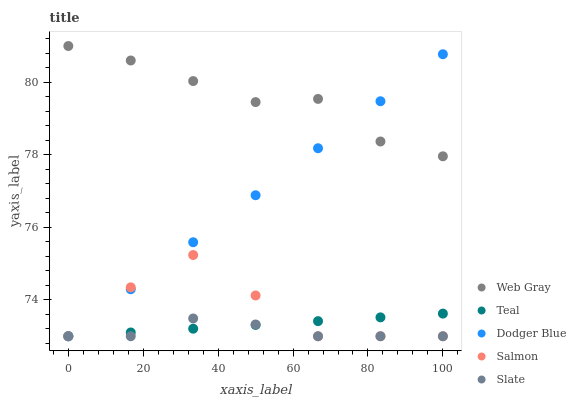Does Slate have the minimum area under the curve?
Answer yes or no. Yes. Does Web Gray have the maximum area under the curve?
Answer yes or no. Yes. Does Web Gray have the minimum area under the curve?
Answer yes or no. No. Does Slate have the maximum area under the curve?
Answer yes or no. No. Is Teal the smoothest?
Answer yes or no. Yes. Is Salmon the roughest?
Answer yes or no. Yes. Is Slate the smoothest?
Answer yes or no. No. Is Slate the roughest?
Answer yes or no. No. Does Salmon have the lowest value?
Answer yes or no. Yes. Does Web Gray have the lowest value?
Answer yes or no. No. Does Web Gray have the highest value?
Answer yes or no. Yes. Does Slate have the highest value?
Answer yes or no. No. Is Teal less than Web Gray?
Answer yes or no. Yes. Is Web Gray greater than Slate?
Answer yes or no. Yes. Does Salmon intersect Slate?
Answer yes or no. Yes. Is Salmon less than Slate?
Answer yes or no. No. Is Salmon greater than Slate?
Answer yes or no. No. Does Teal intersect Web Gray?
Answer yes or no. No. 